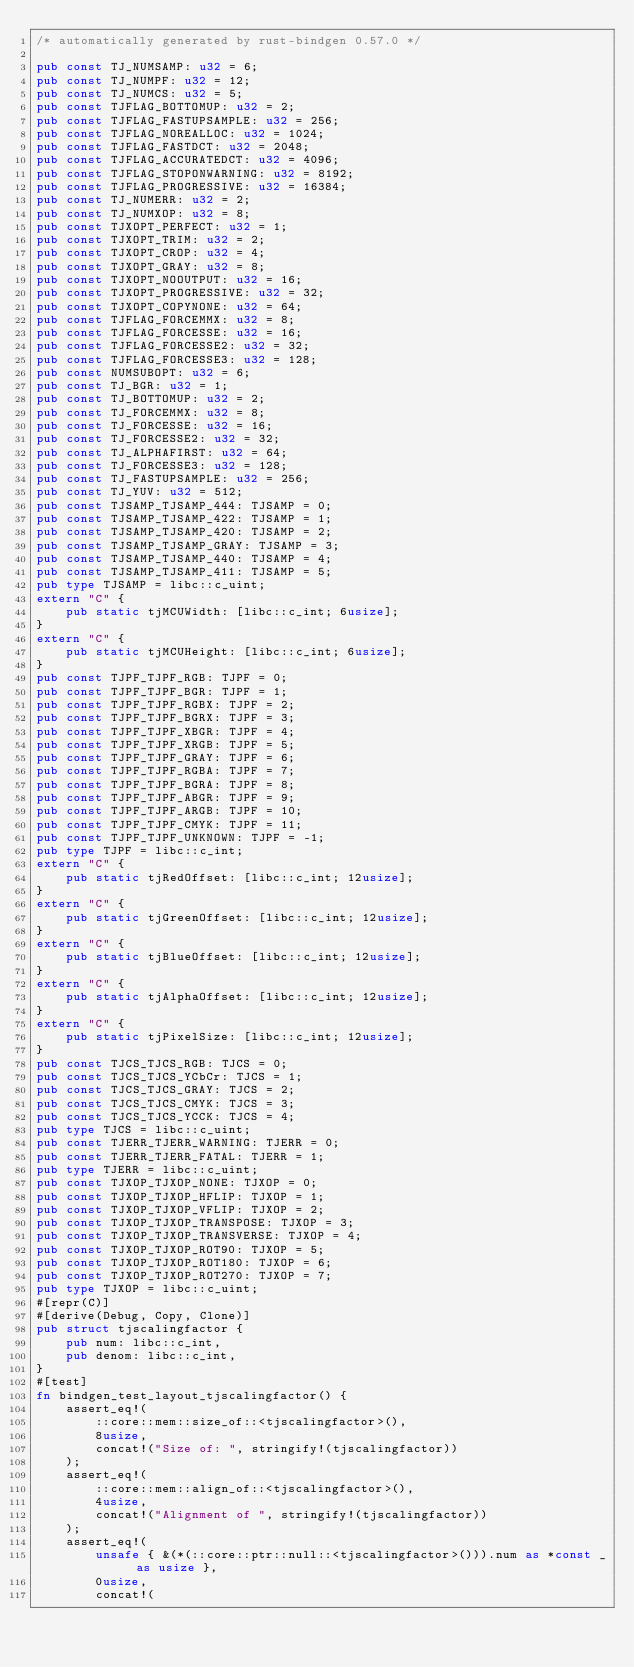Convert code to text. <code><loc_0><loc_0><loc_500><loc_500><_Rust_>/* automatically generated by rust-bindgen 0.57.0 */

pub const TJ_NUMSAMP: u32 = 6;
pub const TJ_NUMPF: u32 = 12;
pub const TJ_NUMCS: u32 = 5;
pub const TJFLAG_BOTTOMUP: u32 = 2;
pub const TJFLAG_FASTUPSAMPLE: u32 = 256;
pub const TJFLAG_NOREALLOC: u32 = 1024;
pub const TJFLAG_FASTDCT: u32 = 2048;
pub const TJFLAG_ACCURATEDCT: u32 = 4096;
pub const TJFLAG_STOPONWARNING: u32 = 8192;
pub const TJFLAG_PROGRESSIVE: u32 = 16384;
pub const TJ_NUMERR: u32 = 2;
pub const TJ_NUMXOP: u32 = 8;
pub const TJXOPT_PERFECT: u32 = 1;
pub const TJXOPT_TRIM: u32 = 2;
pub const TJXOPT_CROP: u32 = 4;
pub const TJXOPT_GRAY: u32 = 8;
pub const TJXOPT_NOOUTPUT: u32 = 16;
pub const TJXOPT_PROGRESSIVE: u32 = 32;
pub const TJXOPT_COPYNONE: u32 = 64;
pub const TJFLAG_FORCEMMX: u32 = 8;
pub const TJFLAG_FORCESSE: u32 = 16;
pub const TJFLAG_FORCESSE2: u32 = 32;
pub const TJFLAG_FORCESSE3: u32 = 128;
pub const NUMSUBOPT: u32 = 6;
pub const TJ_BGR: u32 = 1;
pub const TJ_BOTTOMUP: u32 = 2;
pub const TJ_FORCEMMX: u32 = 8;
pub const TJ_FORCESSE: u32 = 16;
pub const TJ_FORCESSE2: u32 = 32;
pub const TJ_ALPHAFIRST: u32 = 64;
pub const TJ_FORCESSE3: u32 = 128;
pub const TJ_FASTUPSAMPLE: u32 = 256;
pub const TJ_YUV: u32 = 512;
pub const TJSAMP_TJSAMP_444: TJSAMP = 0;
pub const TJSAMP_TJSAMP_422: TJSAMP = 1;
pub const TJSAMP_TJSAMP_420: TJSAMP = 2;
pub const TJSAMP_TJSAMP_GRAY: TJSAMP = 3;
pub const TJSAMP_TJSAMP_440: TJSAMP = 4;
pub const TJSAMP_TJSAMP_411: TJSAMP = 5;
pub type TJSAMP = libc::c_uint;
extern "C" {
    pub static tjMCUWidth: [libc::c_int; 6usize];
}
extern "C" {
    pub static tjMCUHeight: [libc::c_int; 6usize];
}
pub const TJPF_TJPF_RGB: TJPF = 0;
pub const TJPF_TJPF_BGR: TJPF = 1;
pub const TJPF_TJPF_RGBX: TJPF = 2;
pub const TJPF_TJPF_BGRX: TJPF = 3;
pub const TJPF_TJPF_XBGR: TJPF = 4;
pub const TJPF_TJPF_XRGB: TJPF = 5;
pub const TJPF_TJPF_GRAY: TJPF = 6;
pub const TJPF_TJPF_RGBA: TJPF = 7;
pub const TJPF_TJPF_BGRA: TJPF = 8;
pub const TJPF_TJPF_ABGR: TJPF = 9;
pub const TJPF_TJPF_ARGB: TJPF = 10;
pub const TJPF_TJPF_CMYK: TJPF = 11;
pub const TJPF_TJPF_UNKNOWN: TJPF = -1;
pub type TJPF = libc::c_int;
extern "C" {
    pub static tjRedOffset: [libc::c_int; 12usize];
}
extern "C" {
    pub static tjGreenOffset: [libc::c_int; 12usize];
}
extern "C" {
    pub static tjBlueOffset: [libc::c_int; 12usize];
}
extern "C" {
    pub static tjAlphaOffset: [libc::c_int; 12usize];
}
extern "C" {
    pub static tjPixelSize: [libc::c_int; 12usize];
}
pub const TJCS_TJCS_RGB: TJCS = 0;
pub const TJCS_TJCS_YCbCr: TJCS = 1;
pub const TJCS_TJCS_GRAY: TJCS = 2;
pub const TJCS_TJCS_CMYK: TJCS = 3;
pub const TJCS_TJCS_YCCK: TJCS = 4;
pub type TJCS = libc::c_uint;
pub const TJERR_TJERR_WARNING: TJERR = 0;
pub const TJERR_TJERR_FATAL: TJERR = 1;
pub type TJERR = libc::c_uint;
pub const TJXOP_TJXOP_NONE: TJXOP = 0;
pub const TJXOP_TJXOP_HFLIP: TJXOP = 1;
pub const TJXOP_TJXOP_VFLIP: TJXOP = 2;
pub const TJXOP_TJXOP_TRANSPOSE: TJXOP = 3;
pub const TJXOP_TJXOP_TRANSVERSE: TJXOP = 4;
pub const TJXOP_TJXOP_ROT90: TJXOP = 5;
pub const TJXOP_TJXOP_ROT180: TJXOP = 6;
pub const TJXOP_TJXOP_ROT270: TJXOP = 7;
pub type TJXOP = libc::c_uint;
#[repr(C)]
#[derive(Debug, Copy, Clone)]
pub struct tjscalingfactor {
    pub num: libc::c_int,
    pub denom: libc::c_int,
}
#[test]
fn bindgen_test_layout_tjscalingfactor() {
    assert_eq!(
        ::core::mem::size_of::<tjscalingfactor>(),
        8usize,
        concat!("Size of: ", stringify!(tjscalingfactor))
    );
    assert_eq!(
        ::core::mem::align_of::<tjscalingfactor>(),
        4usize,
        concat!("Alignment of ", stringify!(tjscalingfactor))
    );
    assert_eq!(
        unsafe { &(*(::core::ptr::null::<tjscalingfactor>())).num as *const _ as usize },
        0usize,
        concat!(</code> 